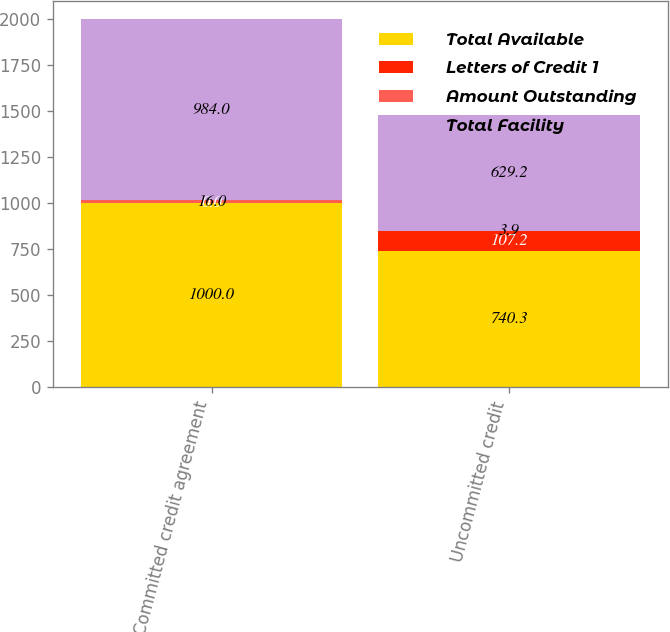<chart> <loc_0><loc_0><loc_500><loc_500><stacked_bar_chart><ecel><fcel>Committed credit agreement<fcel>Uncommitted credit<nl><fcel>Total Available<fcel>1000<fcel>740.3<nl><fcel>Letters of Credit 1<fcel>0<fcel>107.2<nl><fcel>Amount Outstanding<fcel>16<fcel>3.9<nl><fcel>Total Facility<fcel>984<fcel>629.2<nl></chart> 